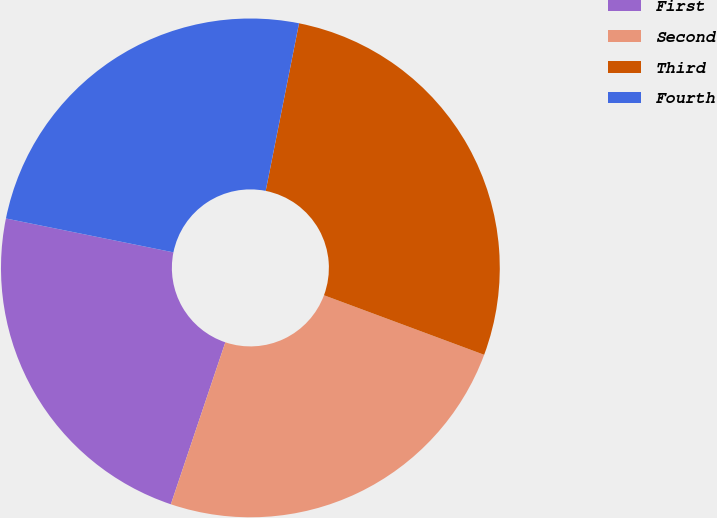Convert chart. <chart><loc_0><loc_0><loc_500><loc_500><pie_chart><fcel>First<fcel>Second<fcel>Third<fcel>Fourth<nl><fcel>23.01%<fcel>24.5%<fcel>27.54%<fcel>24.95%<nl></chart> 